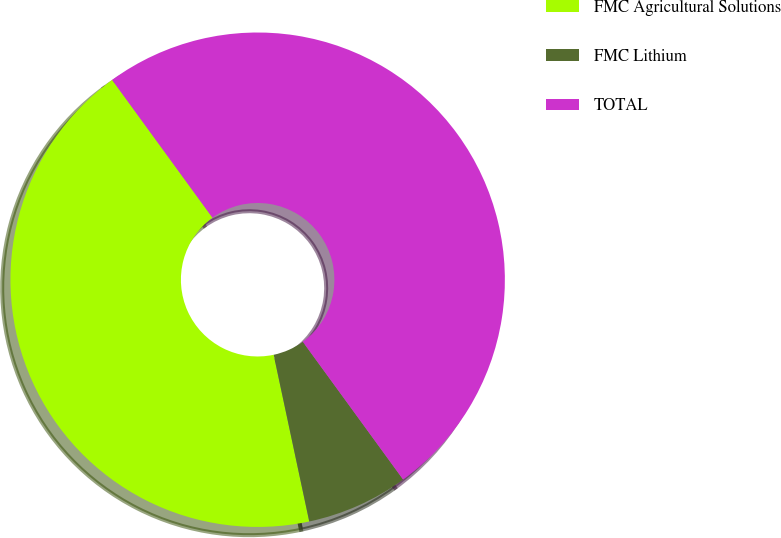<chart> <loc_0><loc_0><loc_500><loc_500><pie_chart><fcel>FMC Agricultural Solutions<fcel>FMC Lithium<fcel>TOTAL<nl><fcel>43.33%<fcel>6.67%<fcel>50.0%<nl></chart> 